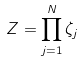<formula> <loc_0><loc_0><loc_500><loc_500>Z = \prod _ { j = 1 } ^ { N } \zeta _ { j }</formula> 